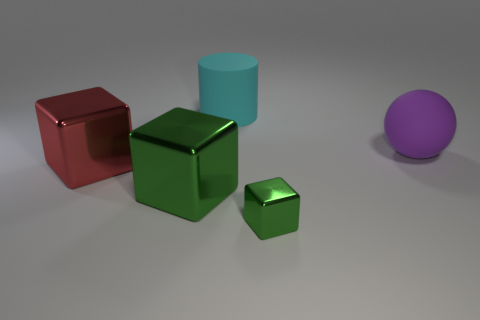Add 3 large green shiny things. How many objects exist? 8 Subtract all spheres. How many objects are left? 4 Subtract all big green matte spheres. Subtract all tiny green objects. How many objects are left? 4 Add 1 large purple things. How many large purple things are left? 2 Add 4 red shiny objects. How many red shiny objects exist? 5 Subtract 0 purple cubes. How many objects are left? 5 